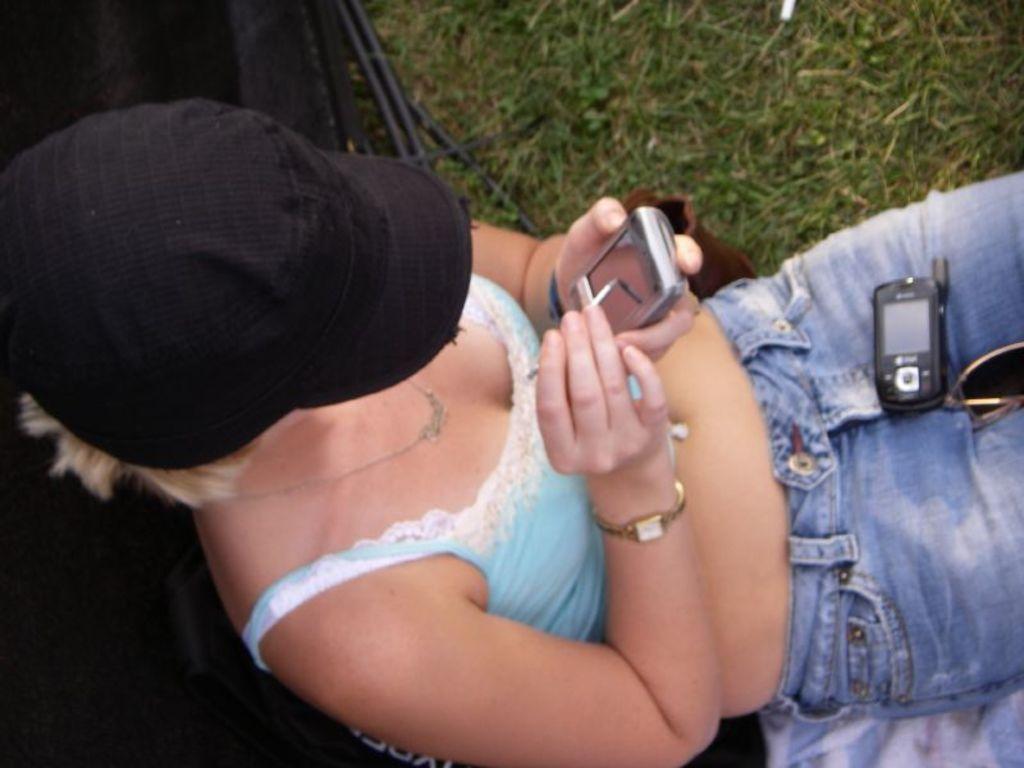Please provide a concise description of this image. In this image, we can see woman is sitting, holding mobile and pin and wearing cap. On her lap, we can see mobile and goggles. Here we can see black color object, cloth, grass and few things. 